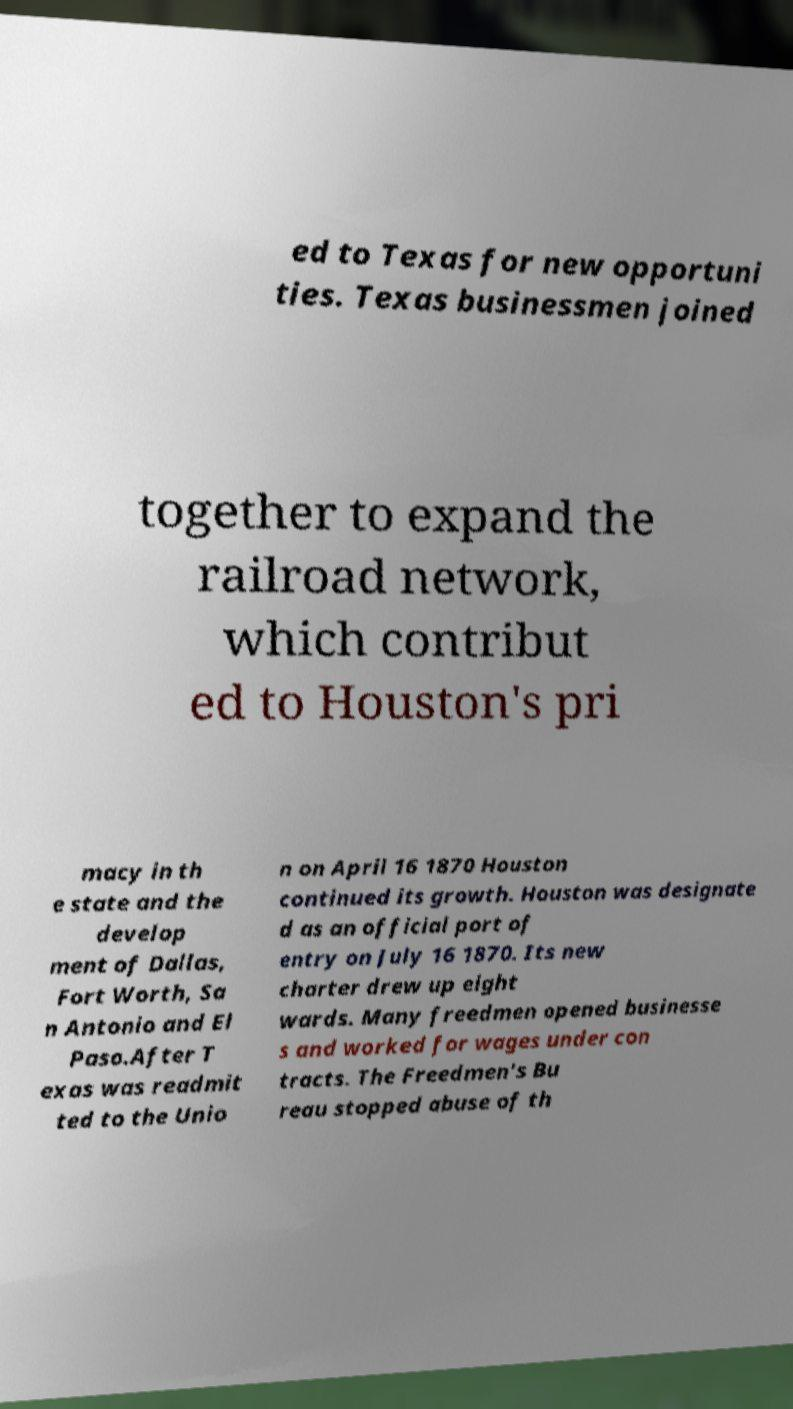For documentation purposes, I need the text within this image transcribed. Could you provide that? ed to Texas for new opportuni ties. Texas businessmen joined together to expand the railroad network, which contribut ed to Houston's pri macy in th e state and the develop ment of Dallas, Fort Worth, Sa n Antonio and El Paso.After T exas was readmit ted to the Unio n on April 16 1870 Houston continued its growth. Houston was designate d as an official port of entry on July 16 1870. Its new charter drew up eight wards. Many freedmen opened businesse s and worked for wages under con tracts. The Freedmen's Bu reau stopped abuse of th 